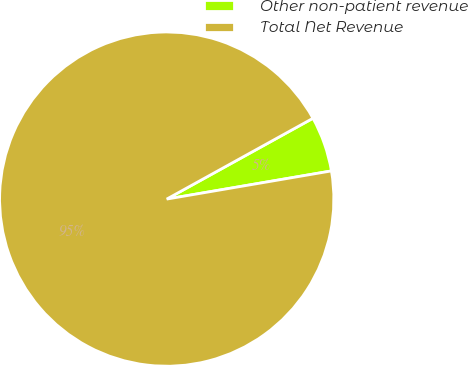Convert chart to OTSL. <chart><loc_0><loc_0><loc_500><loc_500><pie_chart><fcel>Other non-patient revenue<fcel>Total Net Revenue<nl><fcel>5.34%<fcel>94.66%<nl></chart> 